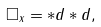Convert formula to latex. <formula><loc_0><loc_0><loc_500><loc_500>\square _ { x } = * d * d ,</formula> 